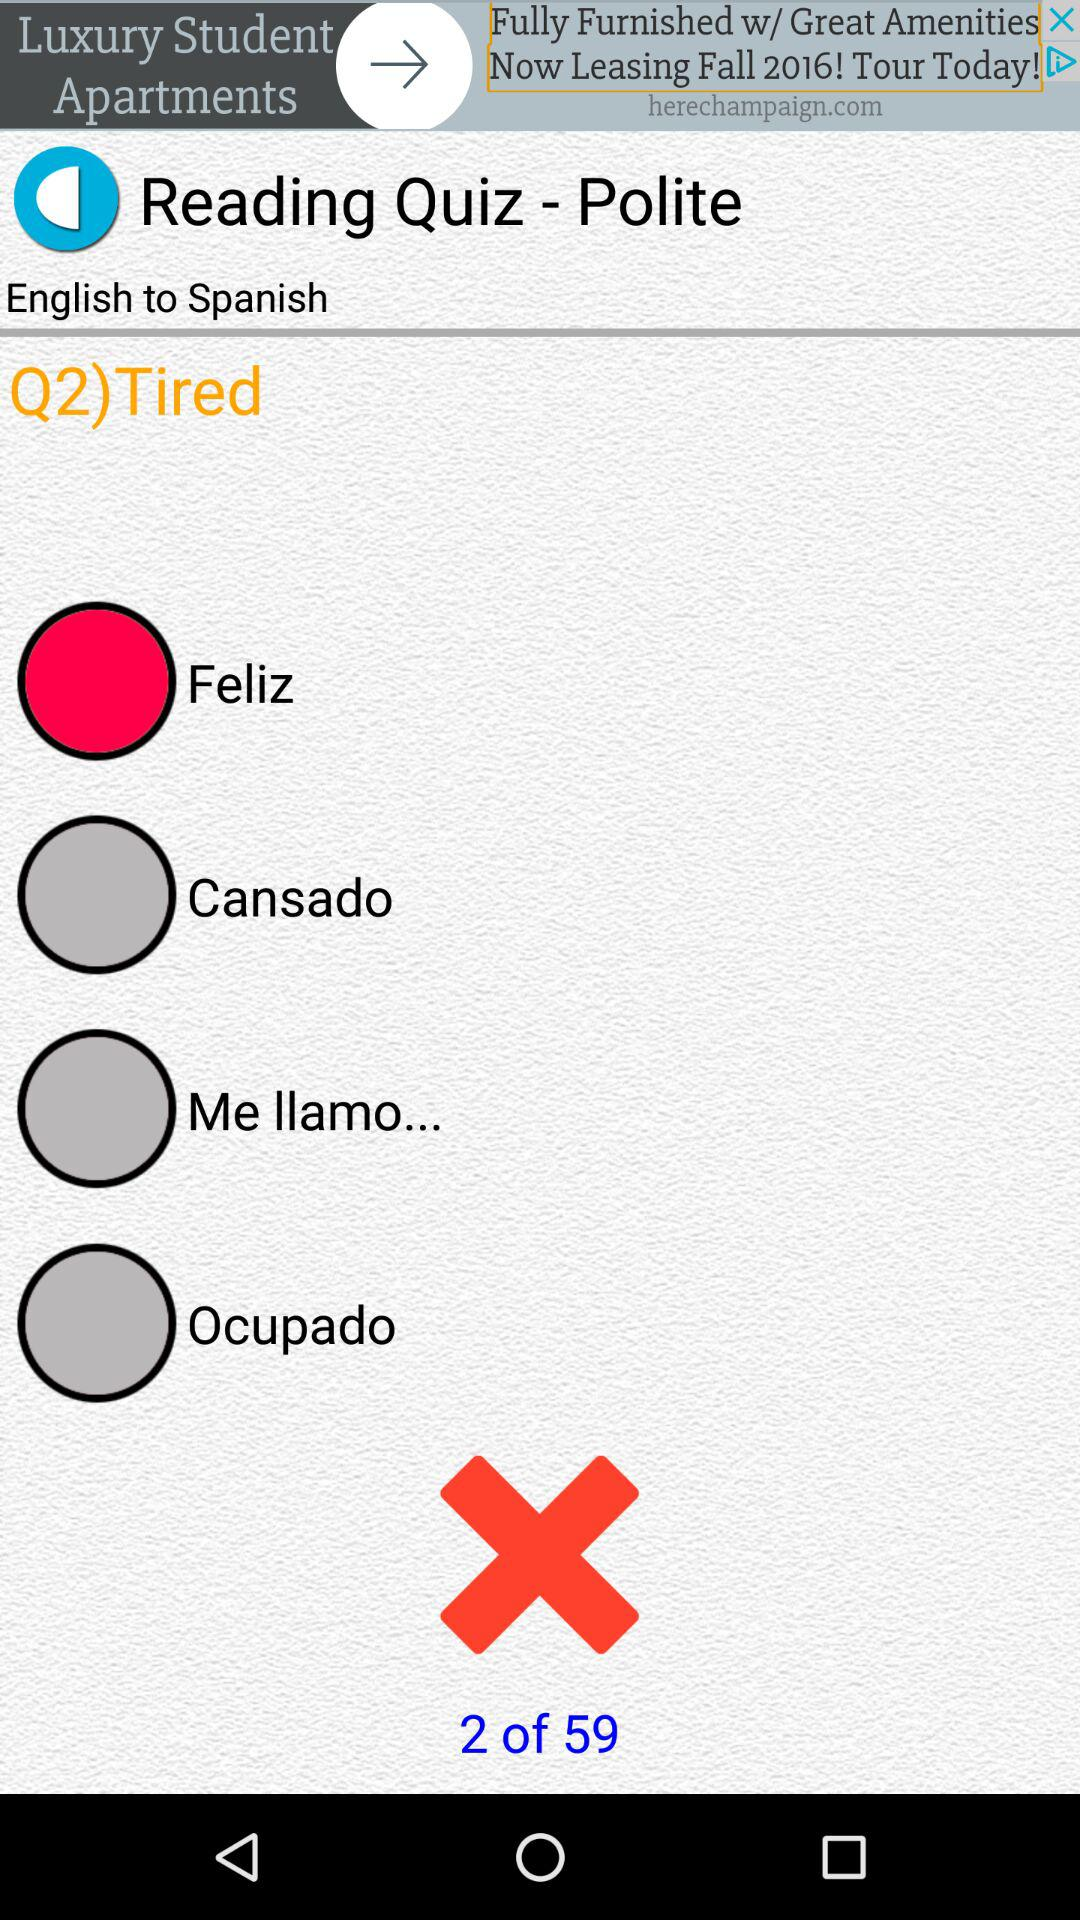What is the meaning of tired in Spanish?
When the provided information is insufficient, respond with <no answer>. <no answer> 